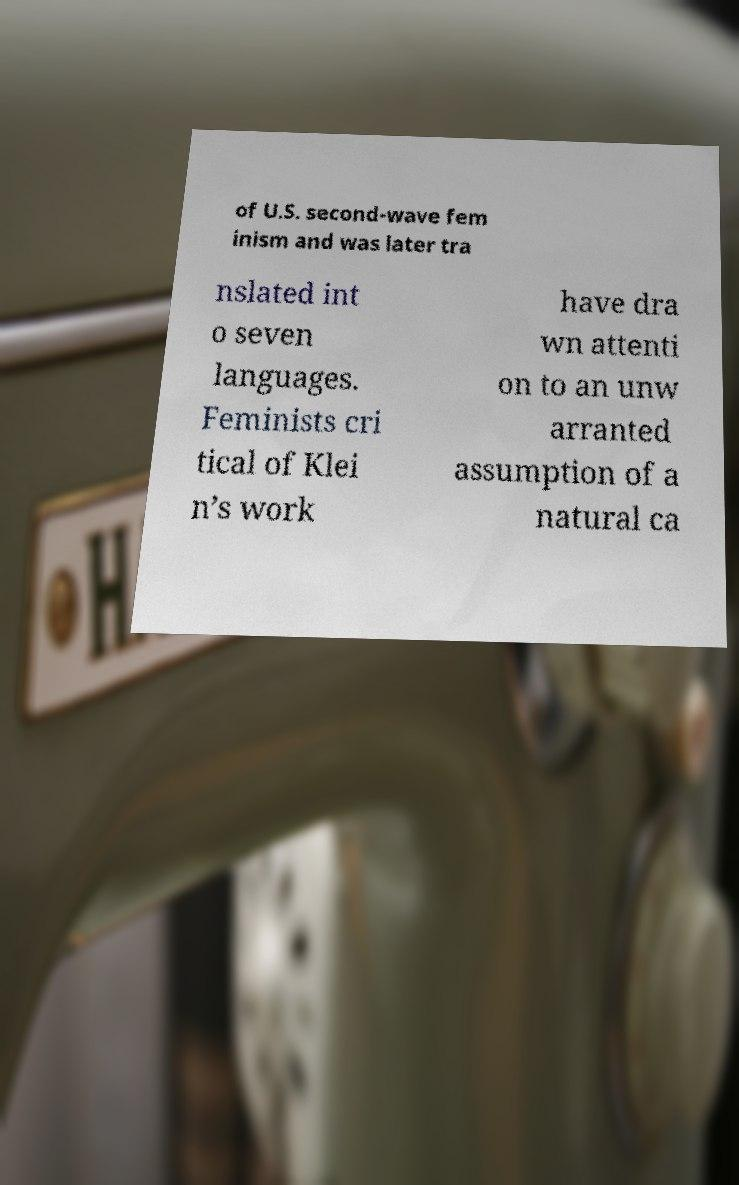For documentation purposes, I need the text within this image transcribed. Could you provide that? of U.S. second-wave fem inism and was later tra nslated int o seven languages. Feminists cri tical of Klei n’s work have dra wn attenti on to an unw arranted assumption of a natural ca 